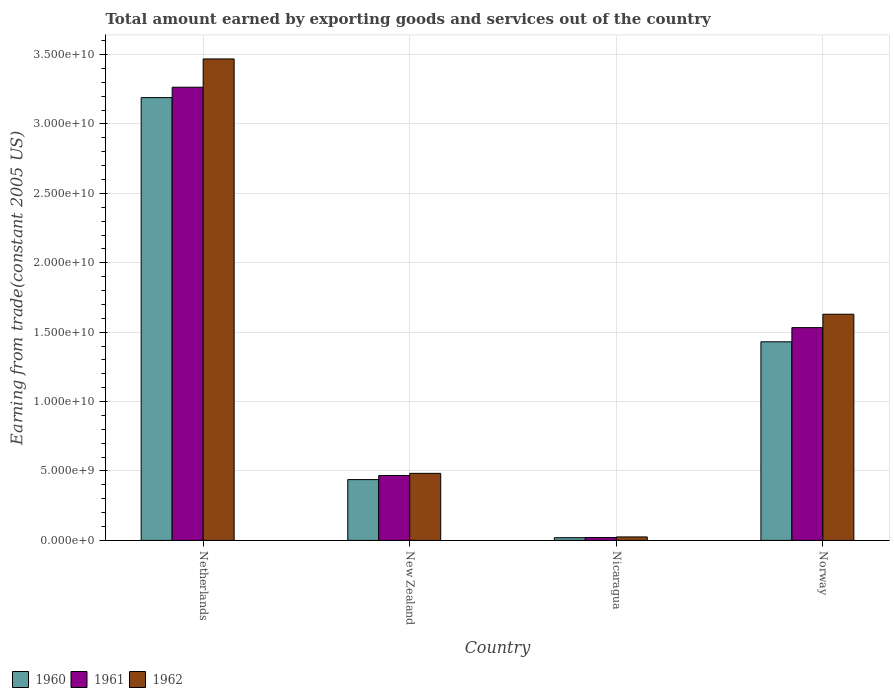How many different coloured bars are there?
Your answer should be very brief. 3. How many groups of bars are there?
Your answer should be very brief. 4. How many bars are there on the 3rd tick from the left?
Your answer should be compact. 3. How many bars are there on the 3rd tick from the right?
Your response must be concise. 3. What is the total amount earned by exporting goods and services in 1960 in Norway?
Provide a succinct answer. 1.43e+1. Across all countries, what is the maximum total amount earned by exporting goods and services in 1961?
Your answer should be very brief. 3.26e+1. Across all countries, what is the minimum total amount earned by exporting goods and services in 1962?
Give a very brief answer. 2.49e+08. In which country was the total amount earned by exporting goods and services in 1962 minimum?
Give a very brief answer. Nicaragua. What is the total total amount earned by exporting goods and services in 1961 in the graph?
Your answer should be very brief. 5.29e+1. What is the difference between the total amount earned by exporting goods and services in 1960 in Netherlands and that in Nicaragua?
Ensure brevity in your answer.  3.17e+1. What is the difference between the total amount earned by exporting goods and services in 1961 in Norway and the total amount earned by exporting goods and services in 1960 in Netherlands?
Your response must be concise. -1.66e+1. What is the average total amount earned by exporting goods and services in 1961 per country?
Offer a very short reply. 1.32e+1. What is the difference between the total amount earned by exporting goods and services of/in 1961 and total amount earned by exporting goods and services of/in 1962 in Nicaragua?
Your response must be concise. -4.35e+07. What is the ratio of the total amount earned by exporting goods and services in 1961 in New Zealand to that in Nicaragua?
Offer a terse response. 22.7. Is the total amount earned by exporting goods and services in 1962 in Netherlands less than that in New Zealand?
Offer a terse response. No. What is the difference between the highest and the second highest total amount earned by exporting goods and services in 1961?
Keep it short and to the point. -2.80e+1. What is the difference between the highest and the lowest total amount earned by exporting goods and services in 1962?
Offer a terse response. 3.44e+1. In how many countries, is the total amount earned by exporting goods and services in 1962 greater than the average total amount earned by exporting goods and services in 1962 taken over all countries?
Your answer should be compact. 2. What is the difference between two consecutive major ticks on the Y-axis?
Make the answer very short. 5.00e+09. Are the values on the major ticks of Y-axis written in scientific E-notation?
Give a very brief answer. Yes. Does the graph contain any zero values?
Provide a succinct answer. No. Where does the legend appear in the graph?
Your answer should be very brief. Bottom left. How many legend labels are there?
Your answer should be very brief. 3. What is the title of the graph?
Ensure brevity in your answer.  Total amount earned by exporting goods and services out of the country. Does "2015" appear as one of the legend labels in the graph?
Your answer should be compact. No. What is the label or title of the Y-axis?
Make the answer very short. Earning from trade(constant 2005 US). What is the Earning from trade(constant 2005 US) in 1960 in Netherlands?
Your response must be concise. 3.19e+1. What is the Earning from trade(constant 2005 US) in 1961 in Netherlands?
Offer a very short reply. 3.26e+1. What is the Earning from trade(constant 2005 US) of 1962 in Netherlands?
Provide a short and direct response. 3.47e+1. What is the Earning from trade(constant 2005 US) in 1960 in New Zealand?
Provide a succinct answer. 4.38e+09. What is the Earning from trade(constant 2005 US) of 1961 in New Zealand?
Your answer should be compact. 4.67e+09. What is the Earning from trade(constant 2005 US) of 1962 in New Zealand?
Ensure brevity in your answer.  4.83e+09. What is the Earning from trade(constant 2005 US) of 1960 in Nicaragua?
Provide a short and direct response. 1.94e+08. What is the Earning from trade(constant 2005 US) in 1961 in Nicaragua?
Keep it short and to the point. 2.06e+08. What is the Earning from trade(constant 2005 US) in 1962 in Nicaragua?
Ensure brevity in your answer.  2.49e+08. What is the Earning from trade(constant 2005 US) of 1960 in Norway?
Your response must be concise. 1.43e+1. What is the Earning from trade(constant 2005 US) in 1961 in Norway?
Provide a succinct answer. 1.53e+1. What is the Earning from trade(constant 2005 US) of 1962 in Norway?
Make the answer very short. 1.63e+1. Across all countries, what is the maximum Earning from trade(constant 2005 US) in 1960?
Provide a short and direct response. 3.19e+1. Across all countries, what is the maximum Earning from trade(constant 2005 US) in 1961?
Provide a succinct answer. 3.26e+1. Across all countries, what is the maximum Earning from trade(constant 2005 US) in 1962?
Offer a very short reply. 3.47e+1. Across all countries, what is the minimum Earning from trade(constant 2005 US) in 1960?
Ensure brevity in your answer.  1.94e+08. Across all countries, what is the minimum Earning from trade(constant 2005 US) of 1961?
Keep it short and to the point. 2.06e+08. Across all countries, what is the minimum Earning from trade(constant 2005 US) of 1962?
Provide a succinct answer. 2.49e+08. What is the total Earning from trade(constant 2005 US) of 1960 in the graph?
Make the answer very short. 5.08e+1. What is the total Earning from trade(constant 2005 US) in 1961 in the graph?
Make the answer very short. 5.29e+1. What is the total Earning from trade(constant 2005 US) in 1962 in the graph?
Give a very brief answer. 5.61e+1. What is the difference between the Earning from trade(constant 2005 US) in 1960 in Netherlands and that in New Zealand?
Offer a terse response. 2.75e+1. What is the difference between the Earning from trade(constant 2005 US) in 1961 in Netherlands and that in New Zealand?
Provide a short and direct response. 2.80e+1. What is the difference between the Earning from trade(constant 2005 US) of 1962 in Netherlands and that in New Zealand?
Make the answer very short. 2.99e+1. What is the difference between the Earning from trade(constant 2005 US) in 1960 in Netherlands and that in Nicaragua?
Your response must be concise. 3.17e+1. What is the difference between the Earning from trade(constant 2005 US) of 1961 in Netherlands and that in Nicaragua?
Ensure brevity in your answer.  3.24e+1. What is the difference between the Earning from trade(constant 2005 US) of 1962 in Netherlands and that in Nicaragua?
Keep it short and to the point. 3.44e+1. What is the difference between the Earning from trade(constant 2005 US) in 1960 in Netherlands and that in Norway?
Offer a terse response. 1.76e+1. What is the difference between the Earning from trade(constant 2005 US) in 1961 in Netherlands and that in Norway?
Make the answer very short. 1.73e+1. What is the difference between the Earning from trade(constant 2005 US) of 1962 in Netherlands and that in Norway?
Offer a very short reply. 1.84e+1. What is the difference between the Earning from trade(constant 2005 US) in 1960 in New Zealand and that in Nicaragua?
Provide a short and direct response. 4.19e+09. What is the difference between the Earning from trade(constant 2005 US) of 1961 in New Zealand and that in Nicaragua?
Ensure brevity in your answer.  4.47e+09. What is the difference between the Earning from trade(constant 2005 US) in 1962 in New Zealand and that in Nicaragua?
Ensure brevity in your answer.  4.58e+09. What is the difference between the Earning from trade(constant 2005 US) in 1960 in New Zealand and that in Norway?
Your answer should be compact. -9.93e+09. What is the difference between the Earning from trade(constant 2005 US) of 1961 in New Zealand and that in Norway?
Your answer should be compact. -1.07e+1. What is the difference between the Earning from trade(constant 2005 US) in 1962 in New Zealand and that in Norway?
Ensure brevity in your answer.  -1.15e+1. What is the difference between the Earning from trade(constant 2005 US) in 1960 in Nicaragua and that in Norway?
Your answer should be compact. -1.41e+1. What is the difference between the Earning from trade(constant 2005 US) in 1961 in Nicaragua and that in Norway?
Your answer should be very brief. -1.51e+1. What is the difference between the Earning from trade(constant 2005 US) of 1962 in Nicaragua and that in Norway?
Provide a short and direct response. -1.60e+1. What is the difference between the Earning from trade(constant 2005 US) in 1960 in Netherlands and the Earning from trade(constant 2005 US) in 1961 in New Zealand?
Your answer should be very brief. 2.72e+1. What is the difference between the Earning from trade(constant 2005 US) of 1960 in Netherlands and the Earning from trade(constant 2005 US) of 1962 in New Zealand?
Provide a succinct answer. 2.71e+1. What is the difference between the Earning from trade(constant 2005 US) of 1961 in Netherlands and the Earning from trade(constant 2005 US) of 1962 in New Zealand?
Keep it short and to the point. 2.78e+1. What is the difference between the Earning from trade(constant 2005 US) in 1960 in Netherlands and the Earning from trade(constant 2005 US) in 1961 in Nicaragua?
Your answer should be very brief. 3.17e+1. What is the difference between the Earning from trade(constant 2005 US) in 1960 in Netherlands and the Earning from trade(constant 2005 US) in 1962 in Nicaragua?
Offer a terse response. 3.16e+1. What is the difference between the Earning from trade(constant 2005 US) in 1961 in Netherlands and the Earning from trade(constant 2005 US) in 1962 in Nicaragua?
Your response must be concise. 3.24e+1. What is the difference between the Earning from trade(constant 2005 US) in 1960 in Netherlands and the Earning from trade(constant 2005 US) in 1961 in Norway?
Ensure brevity in your answer.  1.66e+1. What is the difference between the Earning from trade(constant 2005 US) in 1960 in Netherlands and the Earning from trade(constant 2005 US) in 1962 in Norway?
Give a very brief answer. 1.56e+1. What is the difference between the Earning from trade(constant 2005 US) in 1961 in Netherlands and the Earning from trade(constant 2005 US) in 1962 in Norway?
Offer a terse response. 1.64e+1. What is the difference between the Earning from trade(constant 2005 US) of 1960 in New Zealand and the Earning from trade(constant 2005 US) of 1961 in Nicaragua?
Your answer should be compact. 4.17e+09. What is the difference between the Earning from trade(constant 2005 US) in 1960 in New Zealand and the Earning from trade(constant 2005 US) in 1962 in Nicaragua?
Offer a very short reply. 4.13e+09. What is the difference between the Earning from trade(constant 2005 US) of 1961 in New Zealand and the Earning from trade(constant 2005 US) of 1962 in Nicaragua?
Provide a succinct answer. 4.42e+09. What is the difference between the Earning from trade(constant 2005 US) of 1960 in New Zealand and the Earning from trade(constant 2005 US) of 1961 in Norway?
Your answer should be very brief. -1.09e+1. What is the difference between the Earning from trade(constant 2005 US) in 1960 in New Zealand and the Earning from trade(constant 2005 US) in 1962 in Norway?
Your response must be concise. -1.19e+1. What is the difference between the Earning from trade(constant 2005 US) in 1961 in New Zealand and the Earning from trade(constant 2005 US) in 1962 in Norway?
Give a very brief answer. -1.16e+1. What is the difference between the Earning from trade(constant 2005 US) of 1960 in Nicaragua and the Earning from trade(constant 2005 US) of 1961 in Norway?
Your answer should be compact. -1.51e+1. What is the difference between the Earning from trade(constant 2005 US) of 1960 in Nicaragua and the Earning from trade(constant 2005 US) of 1962 in Norway?
Keep it short and to the point. -1.61e+1. What is the difference between the Earning from trade(constant 2005 US) of 1961 in Nicaragua and the Earning from trade(constant 2005 US) of 1962 in Norway?
Provide a short and direct response. -1.61e+1. What is the average Earning from trade(constant 2005 US) of 1960 per country?
Keep it short and to the point. 1.27e+1. What is the average Earning from trade(constant 2005 US) of 1961 per country?
Keep it short and to the point. 1.32e+1. What is the average Earning from trade(constant 2005 US) in 1962 per country?
Make the answer very short. 1.40e+1. What is the difference between the Earning from trade(constant 2005 US) of 1960 and Earning from trade(constant 2005 US) of 1961 in Netherlands?
Ensure brevity in your answer.  -7.48e+08. What is the difference between the Earning from trade(constant 2005 US) in 1960 and Earning from trade(constant 2005 US) in 1962 in Netherlands?
Provide a succinct answer. -2.79e+09. What is the difference between the Earning from trade(constant 2005 US) of 1961 and Earning from trade(constant 2005 US) of 1962 in Netherlands?
Ensure brevity in your answer.  -2.04e+09. What is the difference between the Earning from trade(constant 2005 US) of 1960 and Earning from trade(constant 2005 US) of 1961 in New Zealand?
Your answer should be very brief. -2.93e+08. What is the difference between the Earning from trade(constant 2005 US) of 1960 and Earning from trade(constant 2005 US) of 1962 in New Zealand?
Provide a short and direct response. -4.50e+08. What is the difference between the Earning from trade(constant 2005 US) of 1961 and Earning from trade(constant 2005 US) of 1962 in New Zealand?
Keep it short and to the point. -1.57e+08. What is the difference between the Earning from trade(constant 2005 US) of 1960 and Earning from trade(constant 2005 US) of 1961 in Nicaragua?
Offer a very short reply. -1.16e+07. What is the difference between the Earning from trade(constant 2005 US) in 1960 and Earning from trade(constant 2005 US) in 1962 in Nicaragua?
Make the answer very short. -5.51e+07. What is the difference between the Earning from trade(constant 2005 US) in 1961 and Earning from trade(constant 2005 US) in 1962 in Nicaragua?
Your answer should be very brief. -4.35e+07. What is the difference between the Earning from trade(constant 2005 US) in 1960 and Earning from trade(constant 2005 US) in 1961 in Norway?
Keep it short and to the point. -1.02e+09. What is the difference between the Earning from trade(constant 2005 US) of 1960 and Earning from trade(constant 2005 US) of 1962 in Norway?
Offer a very short reply. -1.99e+09. What is the difference between the Earning from trade(constant 2005 US) of 1961 and Earning from trade(constant 2005 US) of 1962 in Norway?
Offer a terse response. -9.66e+08. What is the ratio of the Earning from trade(constant 2005 US) of 1960 in Netherlands to that in New Zealand?
Give a very brief answer. 7.28. What is the ratio of the Earning from trade(constant 2005 US) of 1961 in Netherlands to that in New Zealand?
Offer a very short reply. 6.99. What is the ratio of the Earning from trade(constant 2005 US) in 1962 in Netherlands to that in New Zealand?
Your answer should be very brief. 7.18. What is the ratio of the Earning from trade(constant 2005 US) of 1960 in Netherlands to that in Nicaragua?
Your response must be concise. 164.27. What is the ratio of the Earning from trade(constant 2005 US) of 1961 in Netherlands to that in Nicaragua?
Offer a very short reply. 158.63. What is the ratio of the Earning from trade(constant 2005 US) of 1962 in Netherlands to that in Nicaragua?
Keep it short and to the point. 139.14. What is the ratio of the Earning from trade(constant 2005 US) in 1960 in Netherlands to that in Norway?
Provide a short and direct response. 2.23. What is the ratio of the Earning from trade(constant 2005 US) of 1961 in Netherlands to that in Norway?
Make the answer very short. 2.13. What is the ratio of the Earning from trade(constant 2005 US) in 1962 in Netherlands to that in Norway?
Ensure brevity in your answer.  2.13. What is the ratio of the Earning from trade(constant 2005 US) in 1960 in New Zealand to that in Nicaragua?
Your answer should be very brief. 22.55. What is the ratio of the Earning from trade(constant 2005 US) of 1961 in New Zealand to that in Nicaragua?
Your response must be concise. 22.7. What is the ratio of the Earning from trade(constant 2005 US) of 1962 in New Zealand to that in Nicaragua?
Your answer should be compact. 19.37. What is the ratio of the Earning from trade(constant 2005 US) in 1960 in New Zealand to that in Norway?
Offer a very short reply. 0.31. What is the ratio of the Earning from trade(constant 2005 US) of 1961 in New Zealand to that in Norway?
Offer a terse response. 0.3. What is the ratio of the Earning from trade(constant 2005 US) in 1962 in New Zealand to that in Norway?
Offer a very short reply. 0.3. What is the ratio of the Earning from trade(constant 2005 US) of 1960 in Nicaragua to that in Norway?
Provide a short and direct response. 0.01. What is the ratio of the Earning from trade(constant 2005 US) of 1961 in Nicaragua to that in Norway?
Your answer should be very brief. 0.01. What is the ratio of the Earning from trade(constant 2005 US) in 1962 in Nicaragua to that in Norway?
Provide a short and direct response. 0.02. What is the difference between the highest and the second highest Earning from trade(constant 2005 US) in 1960?
Your answer should be compact. 1.76e+1. What is the difference between the highest and the second highest Earning from trade(constant 2005 US) of 1961?
Give a very brief answer. 1.73e+1. What is the difference between the highest and the second highest Earning from trade(constant 2005 US) of 1962?
Make the answer very short. 1.84e+1. What is the difference between the highest and the lowest Earning from trade(constant 2005 US) in 1960?
Provide a succinct answer. 3.17e+1. What is the difference between the highest and the lowest Earning from trade(constant 2005 US) in 1961?
Offer a terse response. 3.24e+1. What is the difference between the highest and the lowest Earning from trade(constant 2005 US) in 1962?
Offer a very short reply. 3.44e+1. 